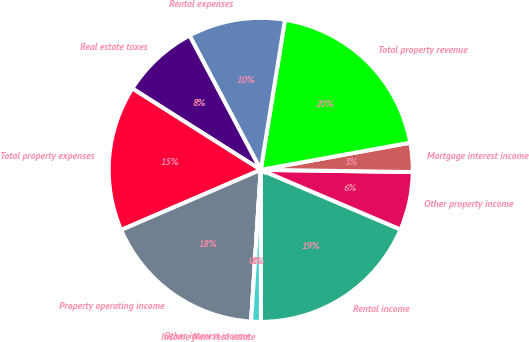Convert chart. <chart><loc_0><loc_0><loc_500><loc_500><pie_chart><fcel>Rental income<fcel>Other property income<fcel>Mortgage interest income<fcel>Total property revenue<fcel>Rental expenses<fcel>Real estate taxes<fcel>Total property expenses<fcel>Property operating income<fcel>Other interest income<fcel>Income from real estate<nl><fcel>18.56%<fcel>6.19%<fcel>3.09%<fcel>19.59%<fcel>10.31%<fcel>8.25%<fcel>15.46%<fcel>17.52%<fcel>0.0%<fcel>1.03%<nl></chart> 